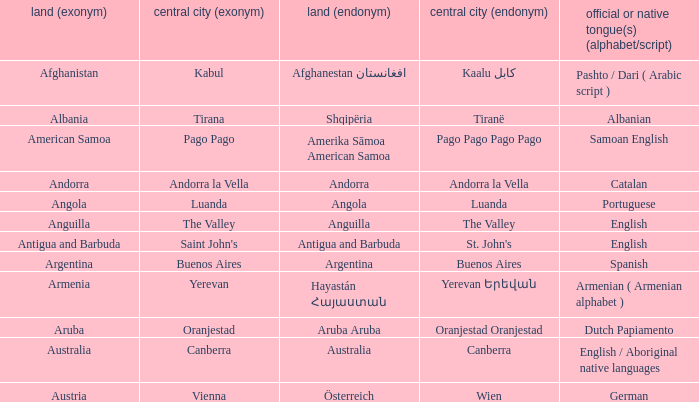What is the English name of the country whose official native language is Dutch Papiamento? Aruba. 